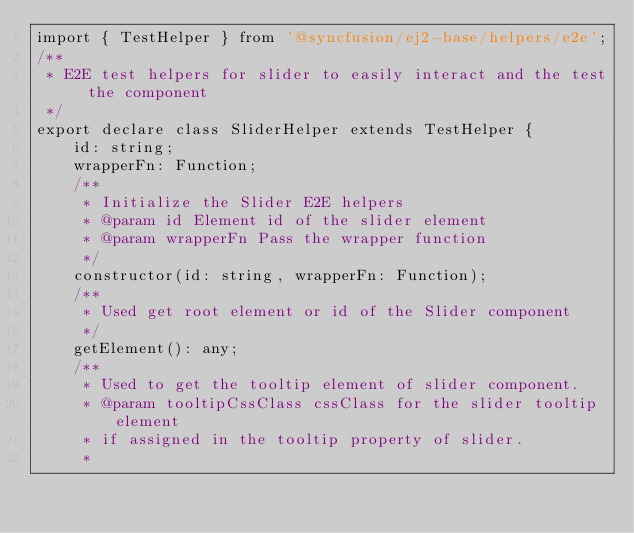Convert code to text. <code><loc_0><loc_0><loc_500><loc_500><_TypeScript_>import { TestHelper } from '@syncfusion/ej2-base/helpers/e2e';
/**
 * E2E test helpers for slider to easily interact and the test the component
 */
export declare class SliderHelper extends TestHelper {
    id: string;
    wrapperFn: Function;
    /**
     * Initialize the Slider E2E helpers
     * @param id Element id of the slider element
     * @param wrapperFn Pass the wrapper function
     */
    constructor(id: string, wrapperFn: Function);
    /**
     * Used get root element or id of the Slider component
     */
    getElement(): any;
    /**
     * Used to get the tooltip element of slider component.
     * @param tooltipCssClass cssClass for the slider tooltip element
     * if assigned in the tooltip property of slider.
     *</code> 